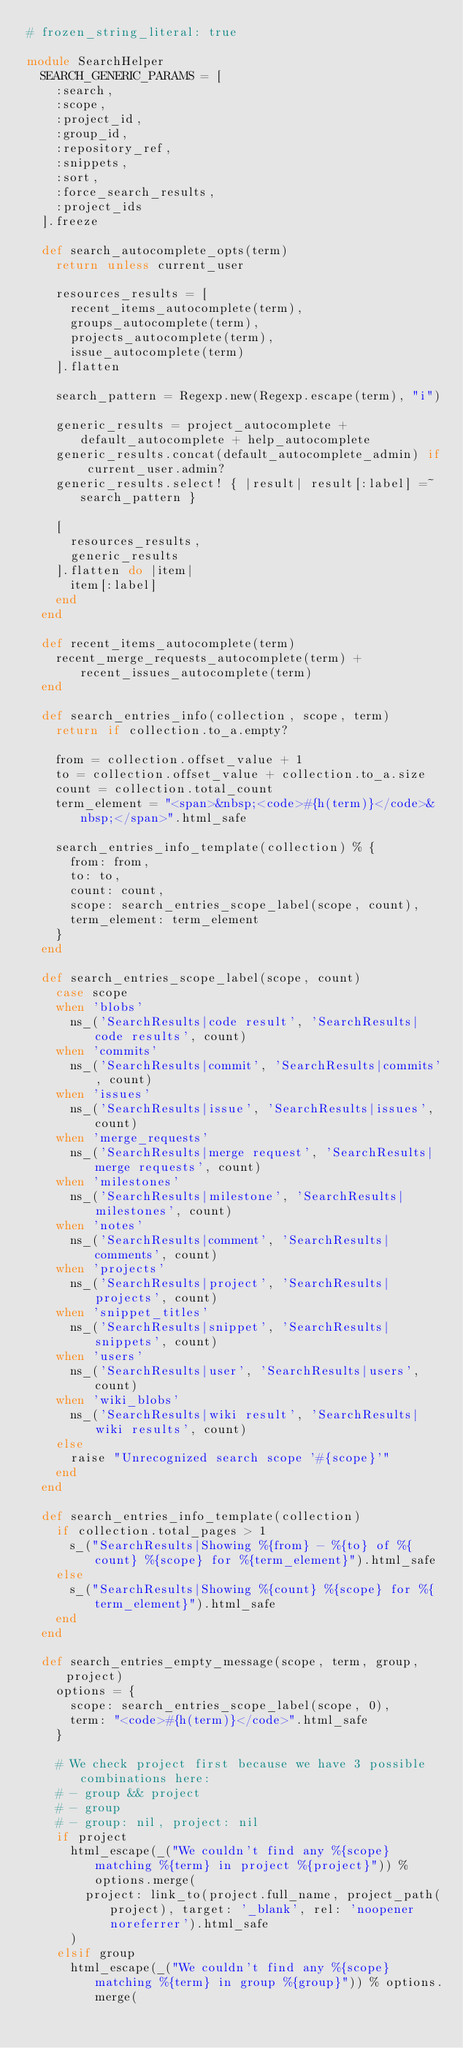<code> <loc_0><loc_0><loc_500><loc_500><_Ruby_># frozen_string_literal: true

module SearchHelper
  SEARCH_GENERIC_PARAMS = [
    :search,
    :scope,
    :project_id,
    :group_id,
    :repository_ref,
    :snippets,
    :sort,
    :force_search_results,
    :project_ids
  ].freeze

  def search_autocomplete_opts(term)
    return unless current_user

    resources_results = [
      recent_items_autocomplete(term),
      groups_autocomplete(term),
      projects_autocomplete(term),
      issue_autocomplete(term)
    ].flatten

    search_pattern = Regexp.new(Regexp.escape(term), "i")

    generic_results = project_autocomplete + default_autocomplete + help_autocomplete
    generic_results.concat(default_autocomplete_admin) if current_user.admin?
    generic_results.select! { |result| result[:label] =~ search_pattern }

    [
      resources_results,
      generic_results
    ].flatten do |item|
      item[:label]
    end
  end

  def recent_items_autocomplete(term)
    recent_merge_requests_autocomplete(term) + recent_issues_autocomplete(term)
  end

  def search_entries_info(collection, scope, term)
    return if collection.to_a.empty?

    from = collection.offset_value + 1
    to = collection.offset_value + collection.to_a.size
    count = collection.total_count
    term_element = "<span>&nbsp;<code>#{h(term)}</code>&nbsp;</span>".html_safe

    search_entries_info_template(collection) % {
      from: from,
      to: to,
      count: count,
      scope: search_entries_scope_label(scope, count),
      term_element: term_element
    }
  end

  def search_entries_scope_label(scope, count)
    case scope
    when 'blobs'
      ns_('SearchResults|code result', 'SearchResults|code results', count)
    when 'commits'
      ns_('SearchResults|commit', 'SearchResults|commits', count)
    when 'issues'
      ns_('SearchResults|issue', 'SearchResults|issues', count)
    when 'merge_requests'
      ns_('SearchResults|merge request', 'SearchResults|merge requests', count)
    when 'milestones'
      ns_('SearchResults|milestone', 'SearchResults|milestones', count)
    when 'notes'
      ns_('SearchResults|comment', 'SearchResults|comments', count)
    when 'projects'
      ns_('SearchResults|project', 'SearchResults|projects', count)
    when 'snippet_titles'
      ns_('SearchResults|snippet', 'SearchResults|snippets', count)
    when 'users'
      ns_('SearchResults|user', 'SearchResults|users', count)
    when 'wiki_blobs'
      ns_('SearchResults|wiki result', 'SearchResults|wiki results', count)
    else
      raise "Unrecognized search scope '#{scope}'"
    end
  end

  def search_entries_info_template(collection)
    if collection.total_pages > 1
      s_("SearchResults|Showing %{from} - %{to} of %{count} %{scope} for %{term_element}").html_safe
    else
      s_("SearchResults|Showing %{count} %{scope} for %{term_element}").html_safe
    end
  end

  def search_entries_empty_message(scope, term, group, project)
    options = {
      scope: search_entries_scope_label(scope, 0),
      term: "<code>#{h(term)}</code>".html_safe
    }

    # We check project first because we have 3 possible combinations here:
    # - group && project
    # - group
    # - group: nil, project: nil
    if project
      html_escape(_("We couldn't find any %{scope} matching %{term} in project %{project}")) % options.merge(
        project: link_to(project.full_name, project_path(project), target: '_blank', rel: 'noopener noreferrer').html_safe
      )
    elsif group
      html_escape(_("We couldn't find any %{scope} matching %{term} in group %{group}")) % options.merge(</code> 